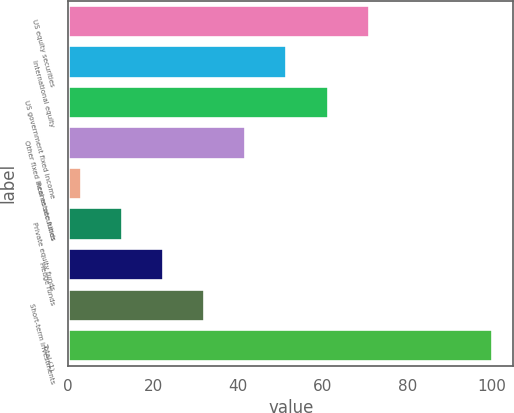Convert chart. <chart><loc_0><loc_0><loc_500><loc_500><bar_chart><fcel>US equity securities<fcel>International equity<fcel>US government fixed income<fcel>Other fixed income securities<fcel>Real estate funds<fcel>Private equity funds<fcel>Hedge funds<fcel>Short-term investments<fcel>Total (1)<nl><fcel>70.9<fcel>51.5<fcel>61.2<fcel>41.8<fcel>3<fcel>12.7<fcel>22.4<fcel>32.1<fcel>100<nl></chart> 